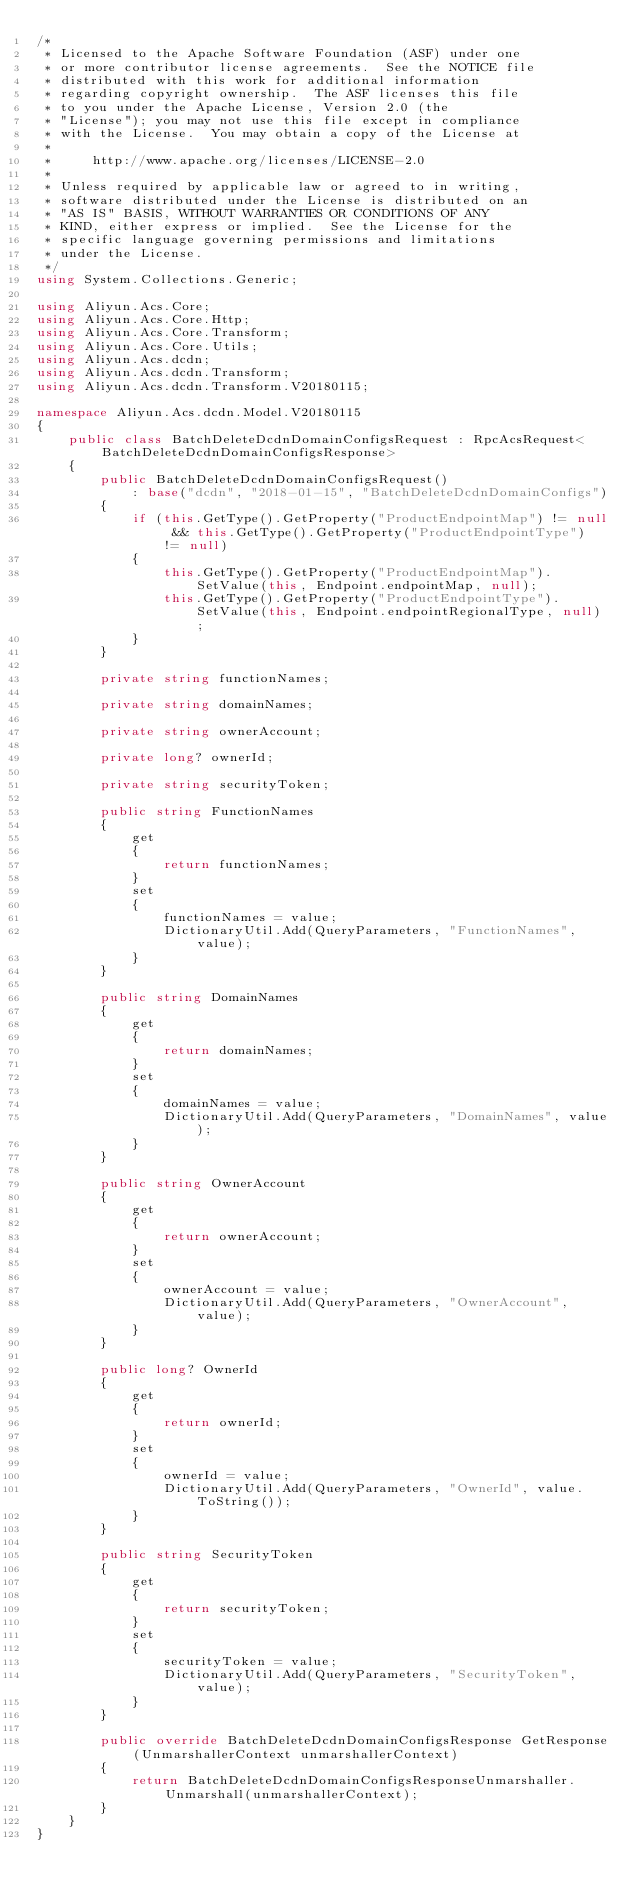Convert code to text. <code><loc_0><loc_0><loc_500><loc_500><_C#_>/*
 * Licensed to the Apache Software Foundation (ASF) under one
 * or more contributor license agreements.  See the NOTICE file
 * distributed with this work for additional information
 * regarding copyright ownership.  The ASF licenses this file
 * to you under the Apache License, Version 2.0 (the
 * "License"); you may not use this file except in compliance
 * with the License.  You may obtain a copy of the License at
 *
 *     http://www.apache.org/licenses/LICENSE-2.0
 *
 * Unless required by applicable law or agreed to in writing,
 * software distributed under the License is distributed on an
 * "AS IS" BASIS, WITHOUT WARRANTIES OR CONDITIONS OF ANY
 * KIND, either express or implied.  See the License for the
 * specific language governing permissions and limitations
 * under the License.
 */
using System.Collections.Generic;

using Aliyun.Acs.Core;
using Aliyun.Acs.Core.Http;
using Aliyun.Acs.Core.Transform;
using Aliyun.Acs.Core.Utils;
using Aliyun.Acs.dcdn;
using Aliyun.Acs.dcdn.Transform;
using Aliyun.Acs.dcdn.Transform.V20180115;

namespace Aliyun.Acs.dcdn.Model.V20180115
{
    public class BatchDeleteDcdnDomainConfigsRequest : RpcAcsRequest<BatchDeleteDcdnDomainConfigsResponse>
    {
        public BatchDeleteDcdnDomainConfigsRequest()
            : base("dcdn", "2018-01-15", "BatchDeleteDcdnDomainConfigs")
        {
            if (this.GetType().GetProperty("ProductEndpointMap") != null && this.GetType().GetProperty("ProductEndpointType") != null)
            {
                this.GetType().GetProperty("ProductEndpointMap").SetValue(this, Endpoint.endpointMap, null);
                this.GetType().GetProperty("ProductEndpointType").SetValue(this, Endpoint.endpointRegionalType, null);
            }
        }

		private string functionNames;

		private string domainNames;

		private string ownerAccount;

		private long? ownerId;

		private string securityToken;

		public string FunctionNames
		{
			get
			{
				return functionNames;
			}
			set	
			{
				functionNames = value;
				DictionaryUtil.Add(QueryParameters, "FunctionNames", value);
			}
		}

		public string DomainNames
		{
			get
			{
				return domainNames;
			}
			set	
			{
				domainNames = value;
				DictionaryUtil.Add(QueryParameters, "DomainNames", value);
			}
		}

		public string OwnerAccount
		{
			get
			{
				return ownerAccount;
			}
			set	
			{
				ownerAccount = value;
				DictionaryUtil.Add(QueryParameters, "OwnerAccount", value);
			}
		}

		public long? OwnerId
		{
			get
			{
				return ownerId;
			}
			set	
			{
				ownerId = value;
				DictionaryUtil.Add(QueryParameters, "OwnerId", value.ToString());
			}
		}

		public string SecurityToken
		{
			get
			{
				return securityToken;
			}
			set	
			{
				securityToken = value;
				DictionaryUtil.Add(QueryParameters, "SecurityToken", value);
			}
		}

        public override BatchDeleteDcdnDomainConfigsResponse GetResponse(UnmarshallerContext unmarshallerContext)
        {
            return BatchDeleteDcdnDomainConfigsResponseUnmarshaller.Unmarshall(unmarshallerContext);
        }
    }
}
</code> 